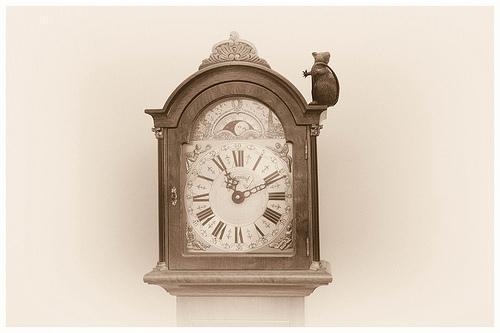How many mice are in the picture?
Give a very brief answer. 1. 